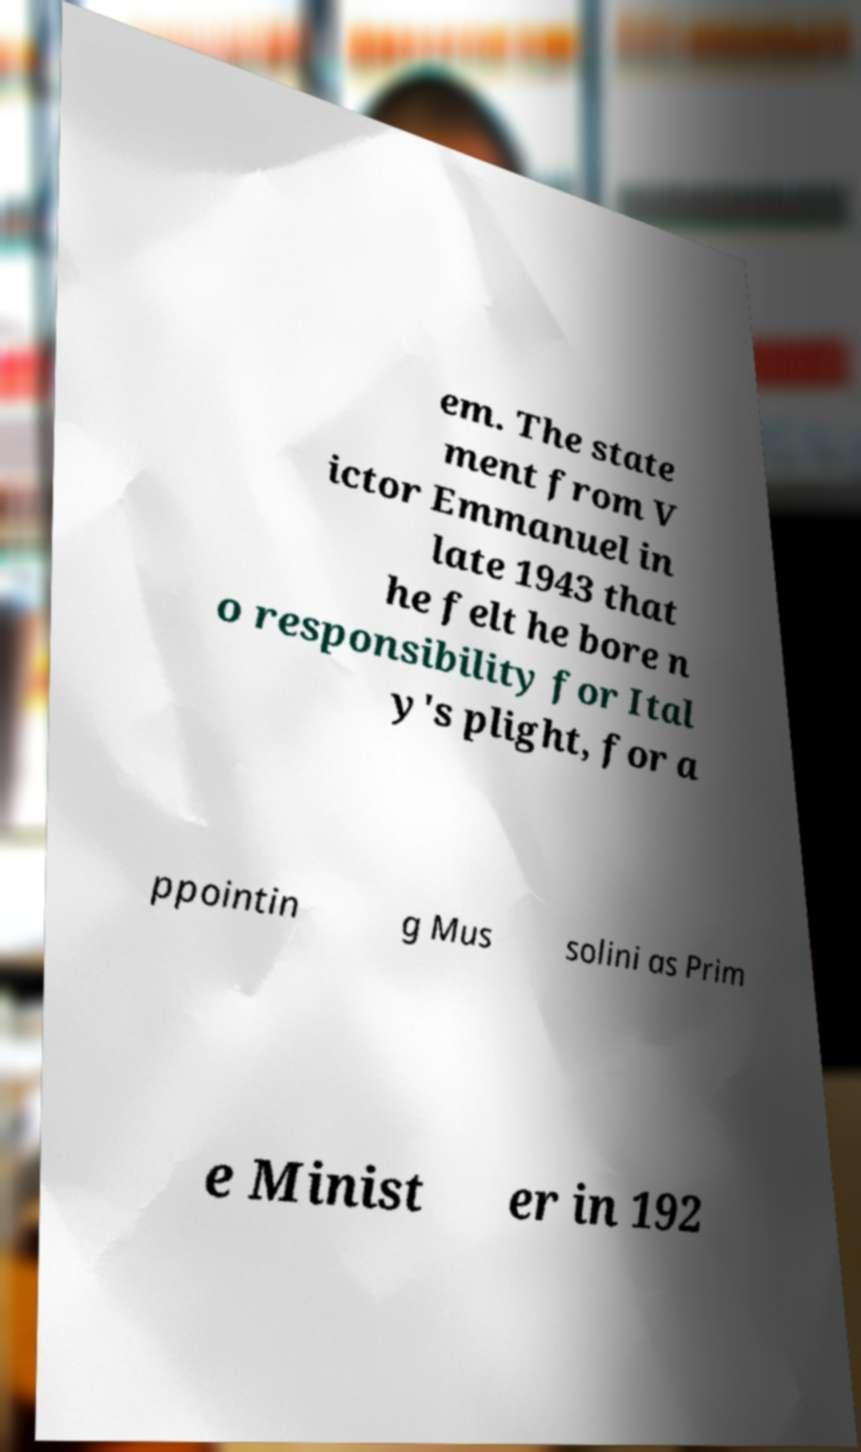Can you accurately transcribe the text from the provided image for me? em. The state ment from V ictor Emmanuel in late 1943 that he felt he bore n o responsibility for Ital y's plight, for a ppointin g Mus solini as Prim e Minist er in 192 